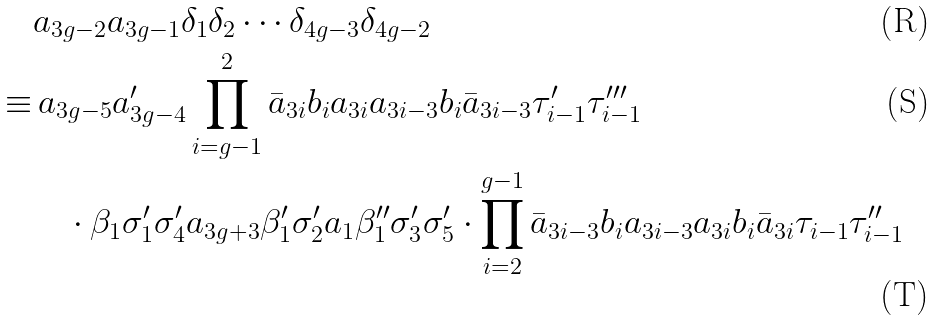Convert formula to latex. <formula><loc_0><loc_0><loc_500><loc_500>& a _ { 3 g - 2 } a _ { 3 g - 1 } \delta _ { 1 } \delta _ { 2 } \cdots \delta _ { 4 g - 3 } \delta _ { 4 g - 2 } \\ \equiv & \, a _ { 3 g - 5 } a ^ { \prime } _ { 3 g - 4 } \prod _ { i = g - 1 } ^ { 2 } \bar { a } _ { 3 i } b _ { i } a _ { 3 i } a _ { 3 i - 3 } b _ { i } \bar { a } _ { 3 i - 3 } \tau ^ { \prime } _ { i - 1 } \tau ^ { \prime \prime \prime } _ { i - 1 } \\ & \quad \cdot \beta _ { 1 } \sigma ^ { \prime } _ { 1 } \sigma ^ { \prime } _ { 4 } a _ { 3 g + 3 } \beta ^ { \prime } _ { 1 } \sigma ^ { \prime } _ { 2 } a _ { 1 } \beta ^ { \prime \prime } _ { 1 } \sigma ^ { \prime } _ { 3 } \sigma ^ { \prime } _ { 5 } \cdot \prod _ { i = 2 } ^ { g - 1 } \bar { a } _ { 3 i - 3 } b _ { i } a _ { 3 i - 3 } a _ { 3 i } b _ { i } \bar { a } _ { 3 i } \tau _ { i - 1 } \tau ^ { \prime \prime } _ { i - 1 }</formula> 